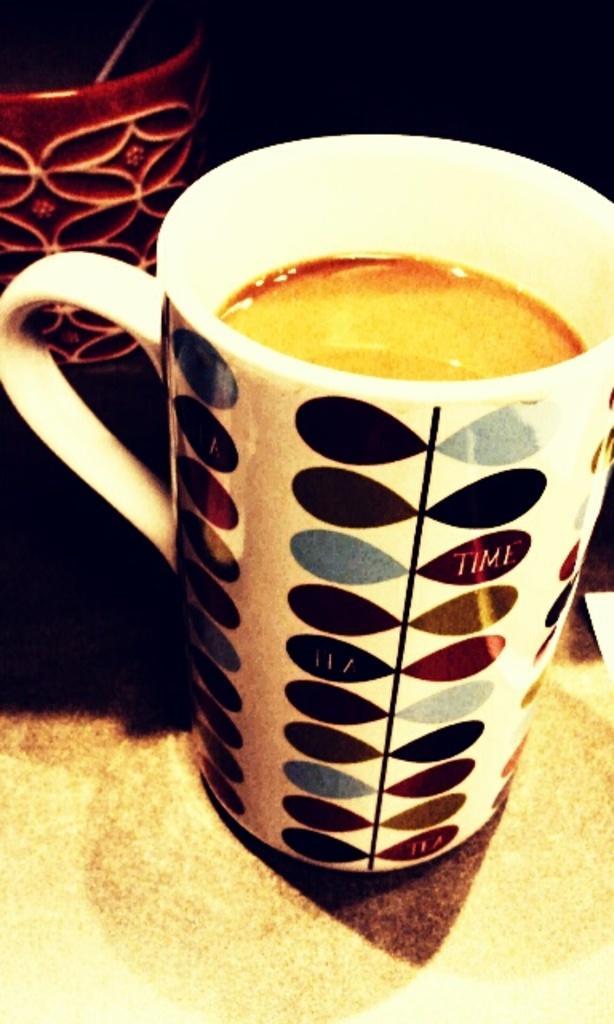How would you summarize this image in a sentence or two? In this picture we can see few cups and we can find drink in the cup, also we can see dark background. 